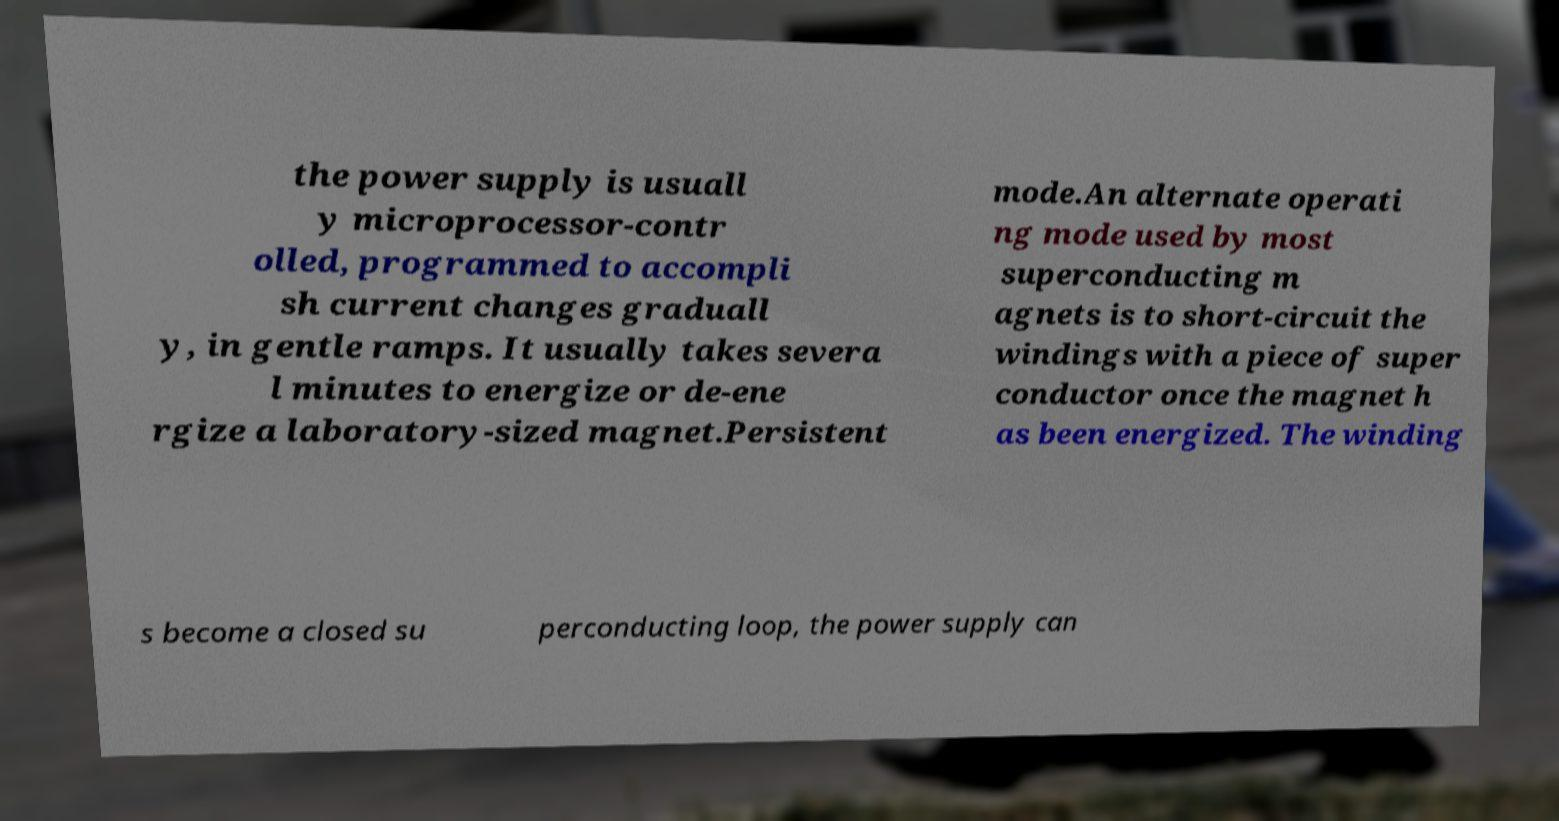Could you assist in decoding the text presented in this image and type it out clearly? the power supply is usuall y microprocessor-contr olled, programmed to accompli sh current changes graduall y, in gentle ramps. It usually takes severa l minutes to energize or de-ene rgize a laboratory-sized magnet.Persistent mode.An alternate operati ng mode used by most superconducting m agnets is to short-circuit the windings with a piece of super conductor once the magnet h as been energized. The winding s become a closed su perconducting loop, the power supply can 